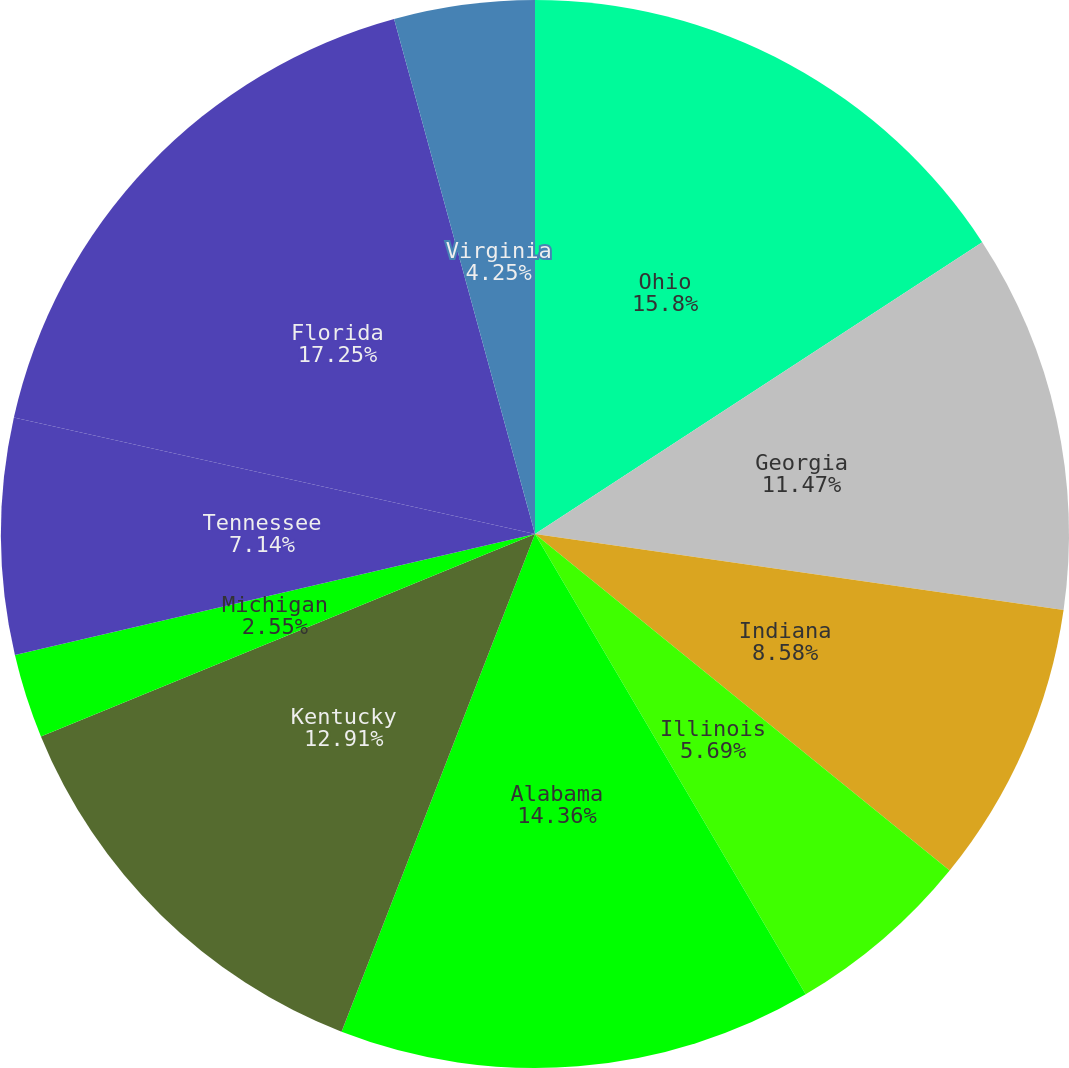Convert chart. <chart><loc_0><loc_0><loc_500><loc_500><pie_chart><fcel>Ohio<fcel>Georgia<fcel>Indiana<fcel>Illinois<fcel>Alabama<fcel>Kentucky<fcel>Michigan<fcel>Tennessee<fcel>Florida<fcel>Virginia<nl><fcel>15.8%<fcel>11.47%<fcel>8.58%<fcel>5.69%<fcel>14.36%<fcel>12.91%<fcel>2.55%<fcel>7.14%<fcel>17.25%<fcel>4.25%<nl></chart> 